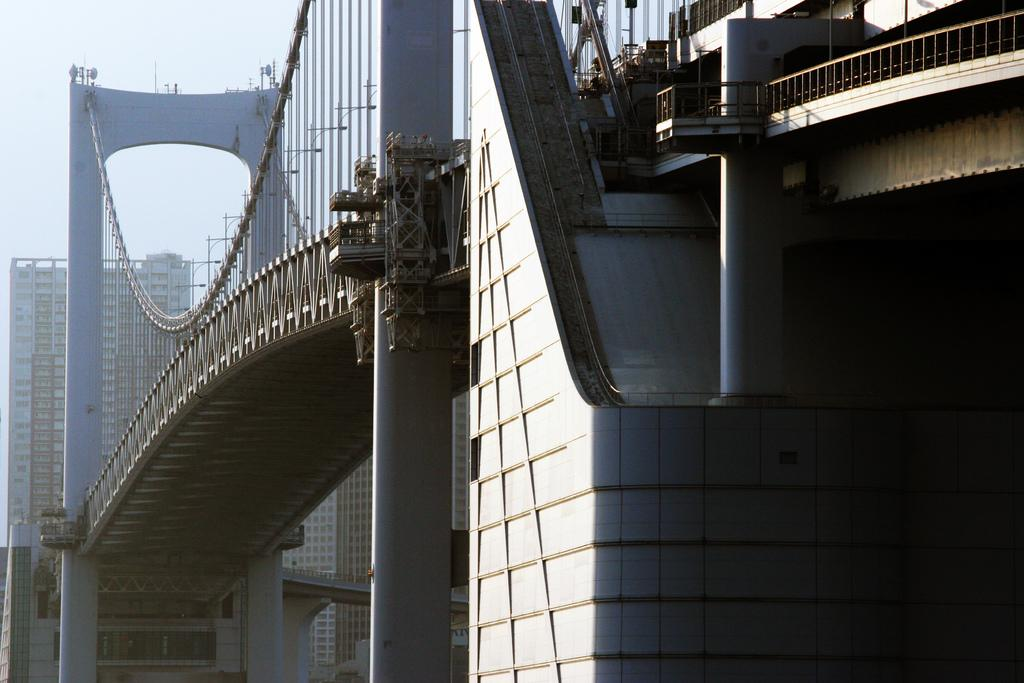What type of structures can be seen in the image? There are buildings in the image. What other objects can be seen in the image? There is a fence and a bridge in the image. What part of the natural environment is visible in the image? The sky is visible in the image. What color are the person's eyes in the image? There is no person present in the image, so it is not possible to determine the color of their eyes. 